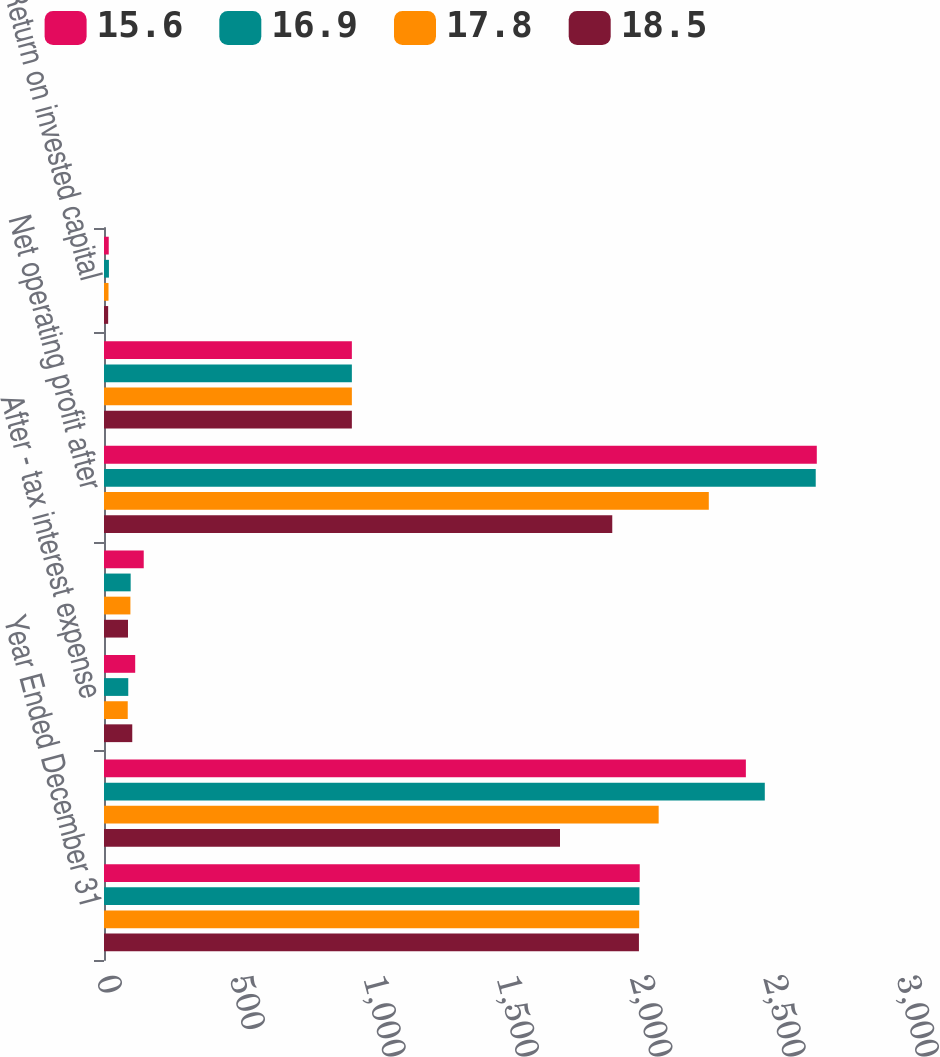Convert chart to OTSL. <chart><loc_0><loc_0><loc_500><loc_500><stacked_bar_chart><ecel><fcel>Year Ended December 31<fcel>Earnings from continuing<fcel>After - tax interest expense<fcel>After - tax amortization<fcel>Net operating profit after<fcel>Average debt and equity<fcel>Return on invested capital<nl><fcel>15.6<fcel>2009<fcel>2407<fcel>117<fcel>149<fcel>2673<fcel>929.5<fcel>17.8<nl><fcel>16.9<fcel>2008<fcel>2478<fcel>91<fcel>100<fcel>2669<fcel>929.5<fcel>18.5<nl><fcel>17.8<fcel>2007<fcel>2080<fcel>89<fcel>99<fcel>2268<fcel>929.5<fcel>16.9<nl><fcel>18.5<fcel>2006<fcel>1710<fcel>106<fcel>90<fcel>1906<fcel>929.5<fcel>15.6<nl></chart> 